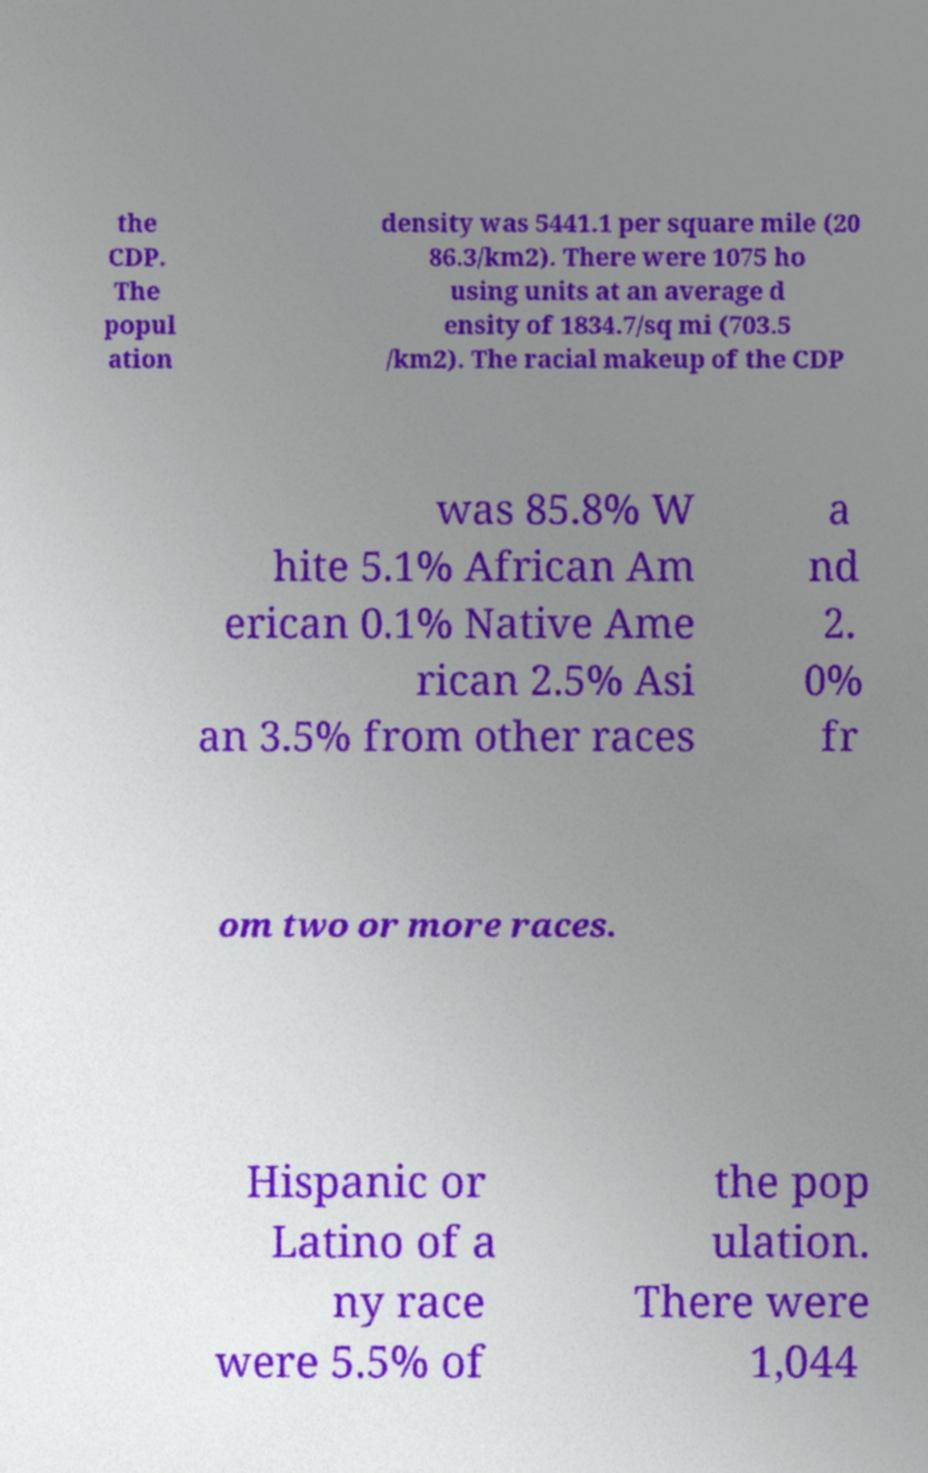What messages or text are displayed in this image? I need them in a readable, typed format. the CDP. The popul ation density was 5441.1 per square mile (20 86.3/km2). There were 1075 ho using units at an average d ensity of 1834.7/sq mi (703.5 /km2). The racial makeup of the CDP was 85.8% W hite 5.1% African Am erican 0.1% Native Ame rican 2.5% Asi an 3.5% from other races a nd 2. 0% fr om two or more races. Hispanic or Latino of a ny race were 5.5% of the pop ulation. There were 1,044 